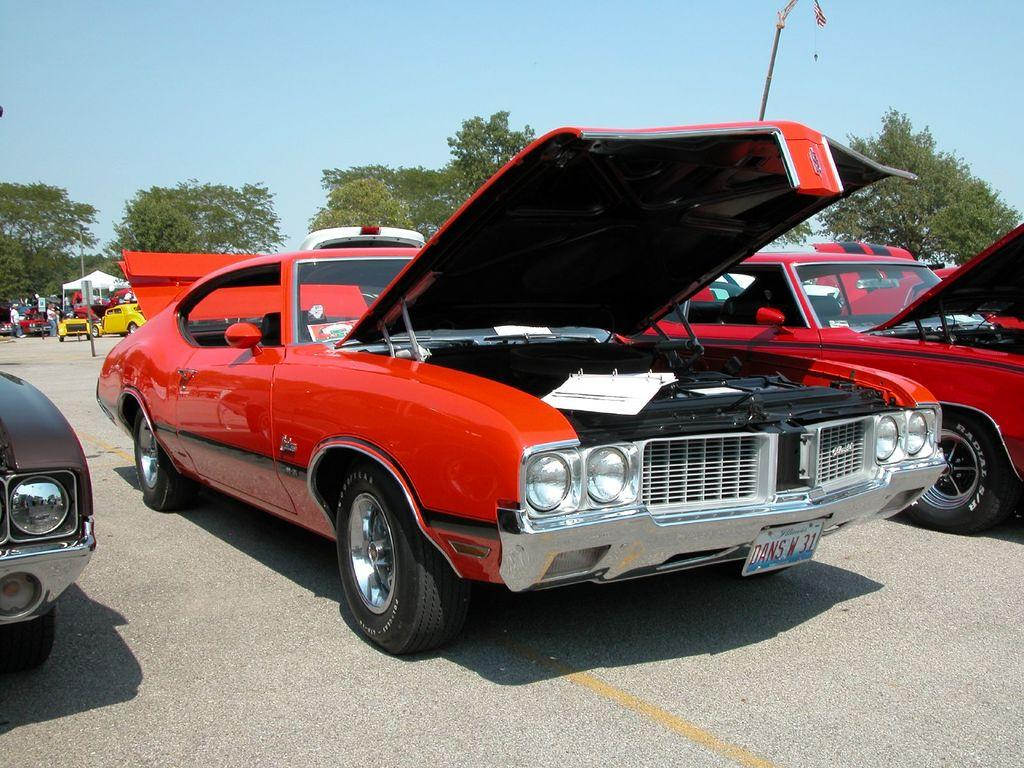What can be seen parked in the image? There are cars parked in the image. What type of natural elements can be seen in the background of the image? There are trees visible in the background of the image. What is the condition of the sky in the image? The sky is clear in the image. What type of paper is being used for treatment in the image? There is no paper or treatment visible in the image; it features parked cars and trees in the background. 